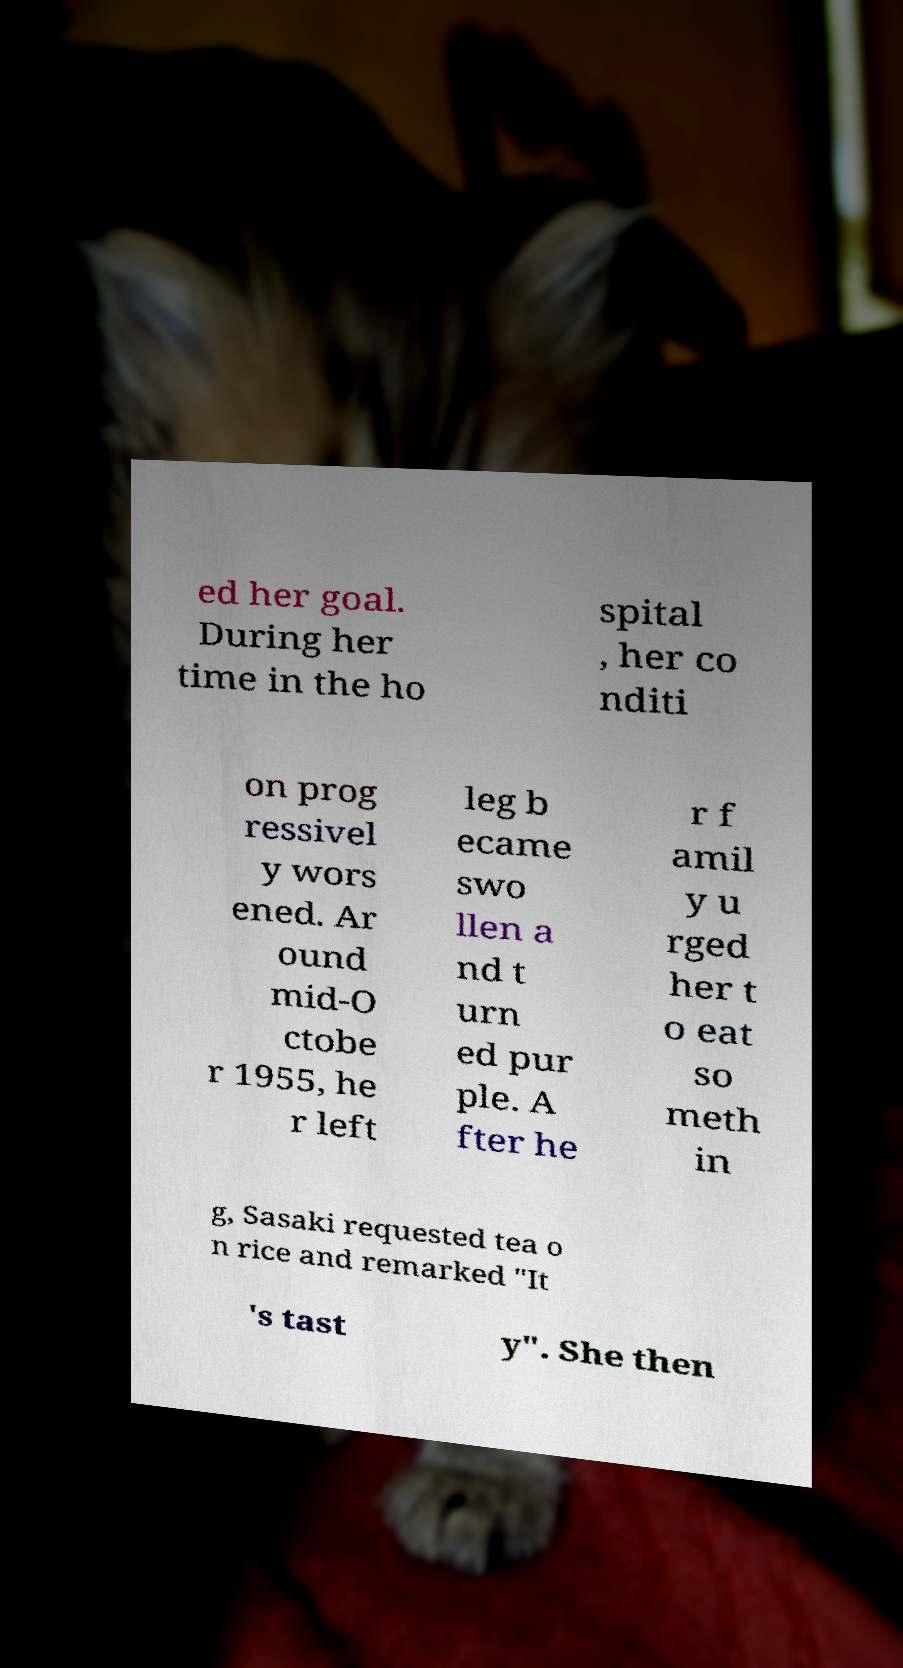Could you assist in decoding the text presented in this image and type it out clearly? ed her goal. During her time in the ho spital , her co nditi on prog ressivel y wors ened. Ar ound mid-O ctobe r 1955, he r left leg b ecame swo llen a nd t urn ed pur ple. A fter he r f amil y u rged her t o eat so meth in g, Sasaki requested tea o n rice and remarked "It 's tast y". She then 